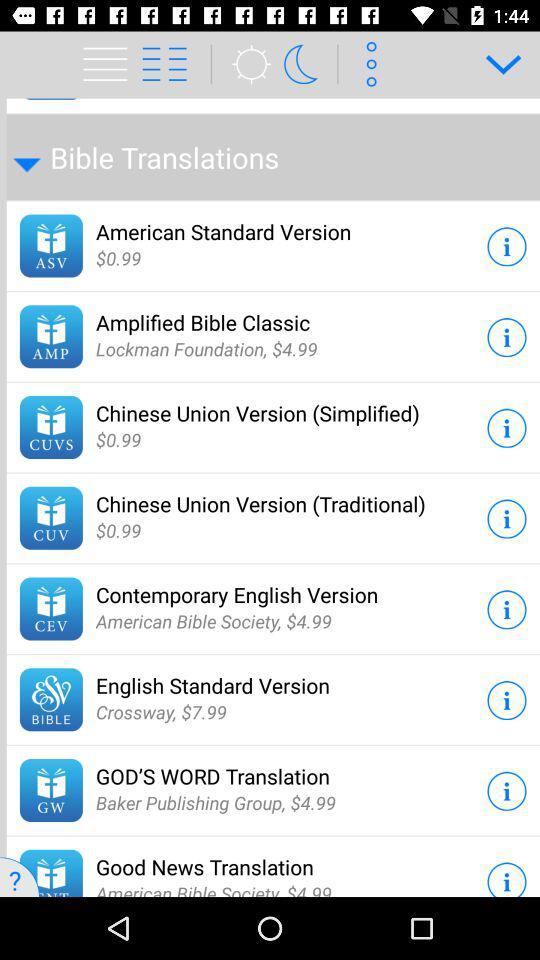Which of the Bible translations has a price of $0.99? The Bible translations are "American Standard Version", "Chinese Union Version (Simplified)", and "Chinese Union Version (Traditional)". 